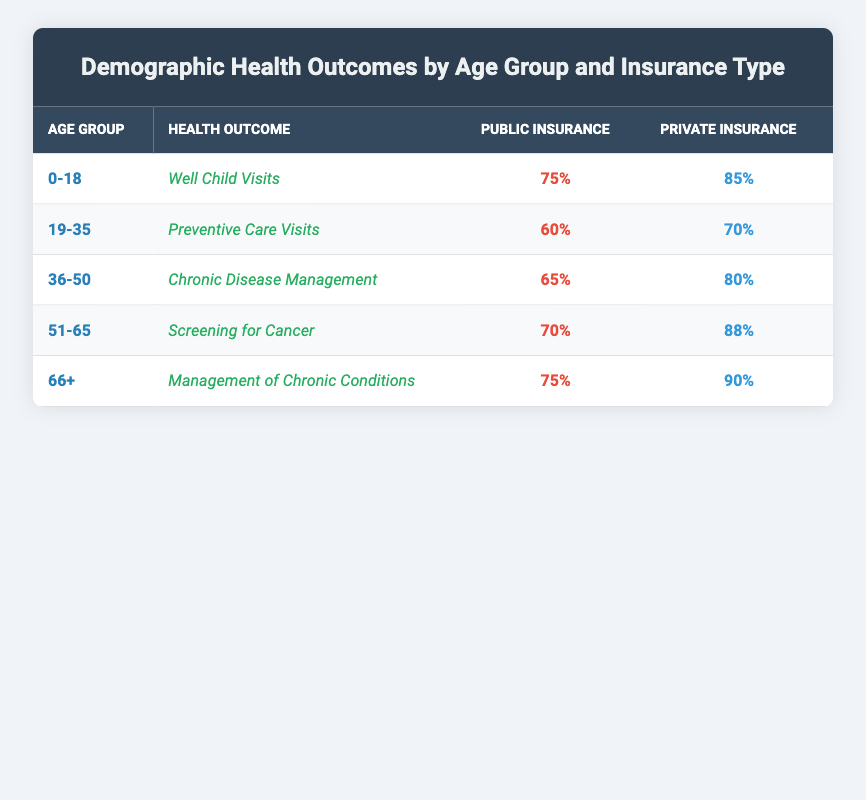What percentage of children aged 0-18 on Public Insurance received Well Child Visits? From the table, the health outcome for the age group 0-18 under Public Insurance shows a percentage of 75% for Well Child Visits.
Answer: 75% Which age group has the highest percentage of preventive care visits under Private Insurance? From the table, the age group 19-35 shows a percentage of 70% for Preventive Care Visits under Private Insurance, which is the highest percentage among the age groups listed.
Answer: 19-35 What is the difference in the percentage of chronic disease management between Public and Private Insurance for the age group 36-50? For the age group 36-50, the percentage for Public Insurance is 65%, and for Private Insurance, it is 80%. The difference is 80% - 65% = 15%.
Answer: 15% Is it true that older adults (ages 66+) with Private Insurance have a higher percentage of management of chronic conditions than those with Public Insurance? The table shows that for the age group 66+, the percentage under Private Insurance is 90%, while under Public Insurance it is 75%. Since 90% is greater than 75%, the statement is true.
Answer: True What is the average percentage of well child visits and management of chronic conditions across all insurance types? For Well Child Visits (75% Public + 85% Private)/2 = 80%, and for Management of Chronic Conditions (75% Public + 90% Private)/2 = 82.5%. The average of these two averages is (80% + 82.5%)/2 = 81.25%.
Answer: 81.25% 